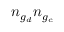<formula> <loc_0><loc_0><loc_500><loc_500>n _ { g _ { d } } n _ { g _ { c } }</formula> 